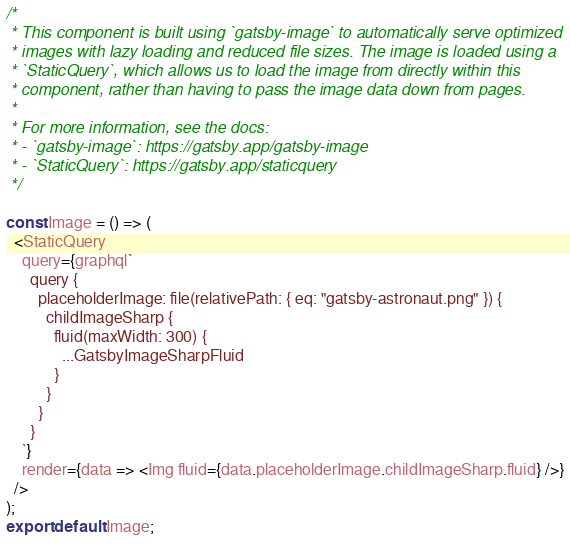Convert code to text. <code><loc_0><loc_0><loc_500><loc_500><_JavaScript_>
/*
 * This component is built using `gatsby-image` to automatically serve optimized
 * images with lazy loading and reduced file sizes. The image is loaded using a
 * `StaticQuery`, which allows us to load the image from directly within this
 * component, rather than having to pass the image data down from pages.
 *
 * For more information, see the docs:
 * - `gatsby-image`: https://gatsby.app/gatsby-image
 * - `StaticQuery`: https://gatsby.app/staticquery
 */

const Image = () => (
  <StaticQuery
    query={graphql`
      query {
        placeholderImage: file(relativePath: { eq: "gatsby-astronaut.png" }) {
          childImageSharp {
            fluid(maxWidth: 300) {
              ...GatsbyImageSharpFluid
            }
          }
        }
      }
    `}
    render={data => <Img fluid={data.placeholderImage.childImageSharp.fluid} />}
  />
);
export default Image;
</code> 